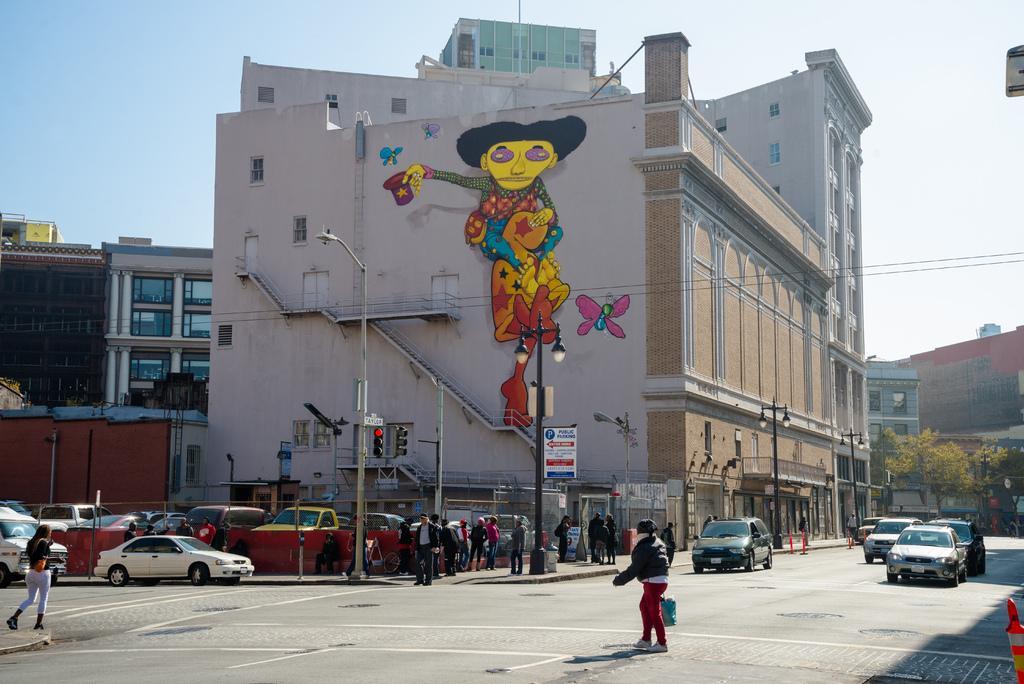Can you describe this image briefly? In this image we can see the buildings, some objects attached to the buildings, some poles with lights, two signal lights with poles, some boards with poles, one board with text on the ground, some vehicles on the roads, some objects on the ground, some trees, one object on the right side of the image, some people are standing, one person sitting, some people are walking, some wires, some people are holding objects, painting on the building wall in the middle of the image and at the top there is the sky. 